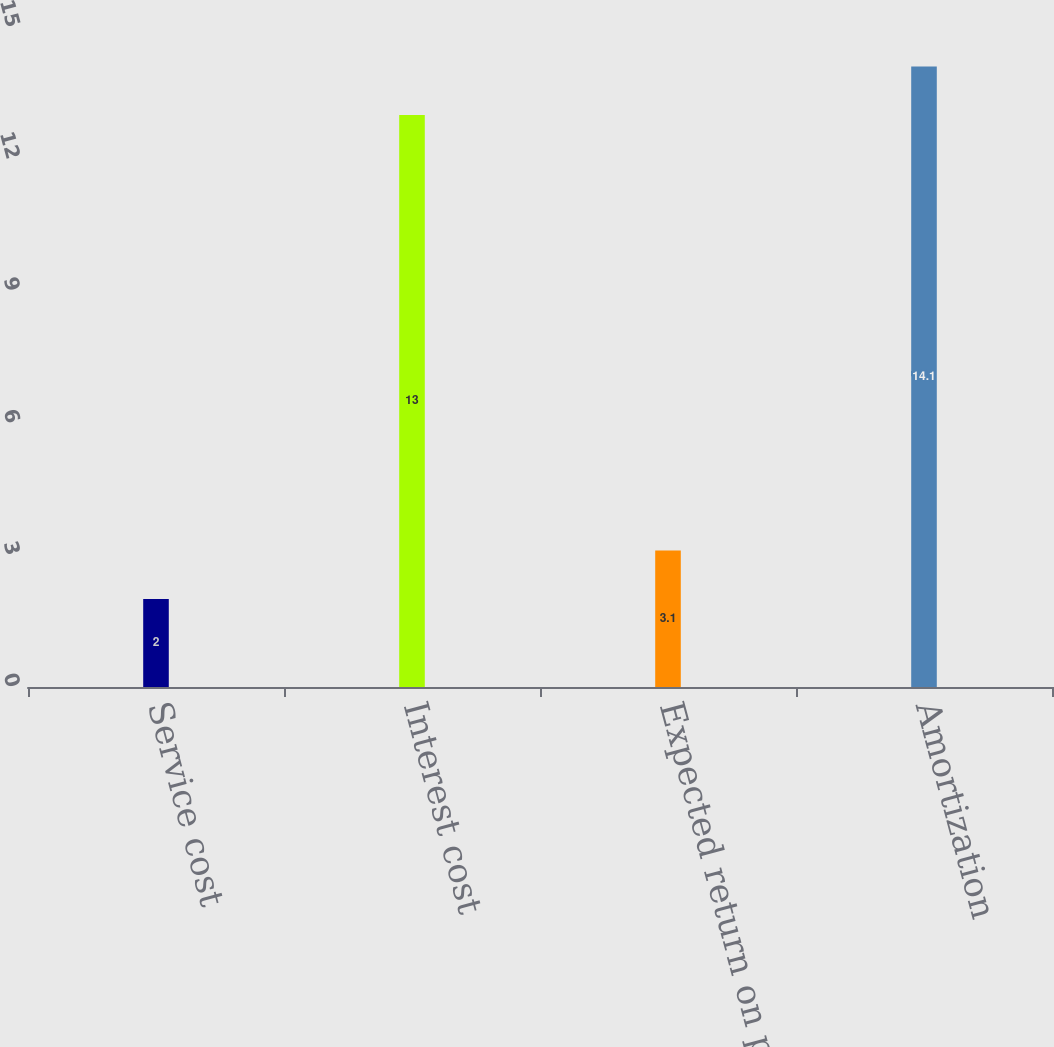Convert chart. <chart><loc_0><loc_0><loc_500><loc_500><bar_chart><fcel>Service cost<fcel>Interest cost<fcel>Expected return on plan assets<fcel>Amortization<nl><fcel>2<fcel>13<fcel>3.1<fcel>14.1<nl></chart> 